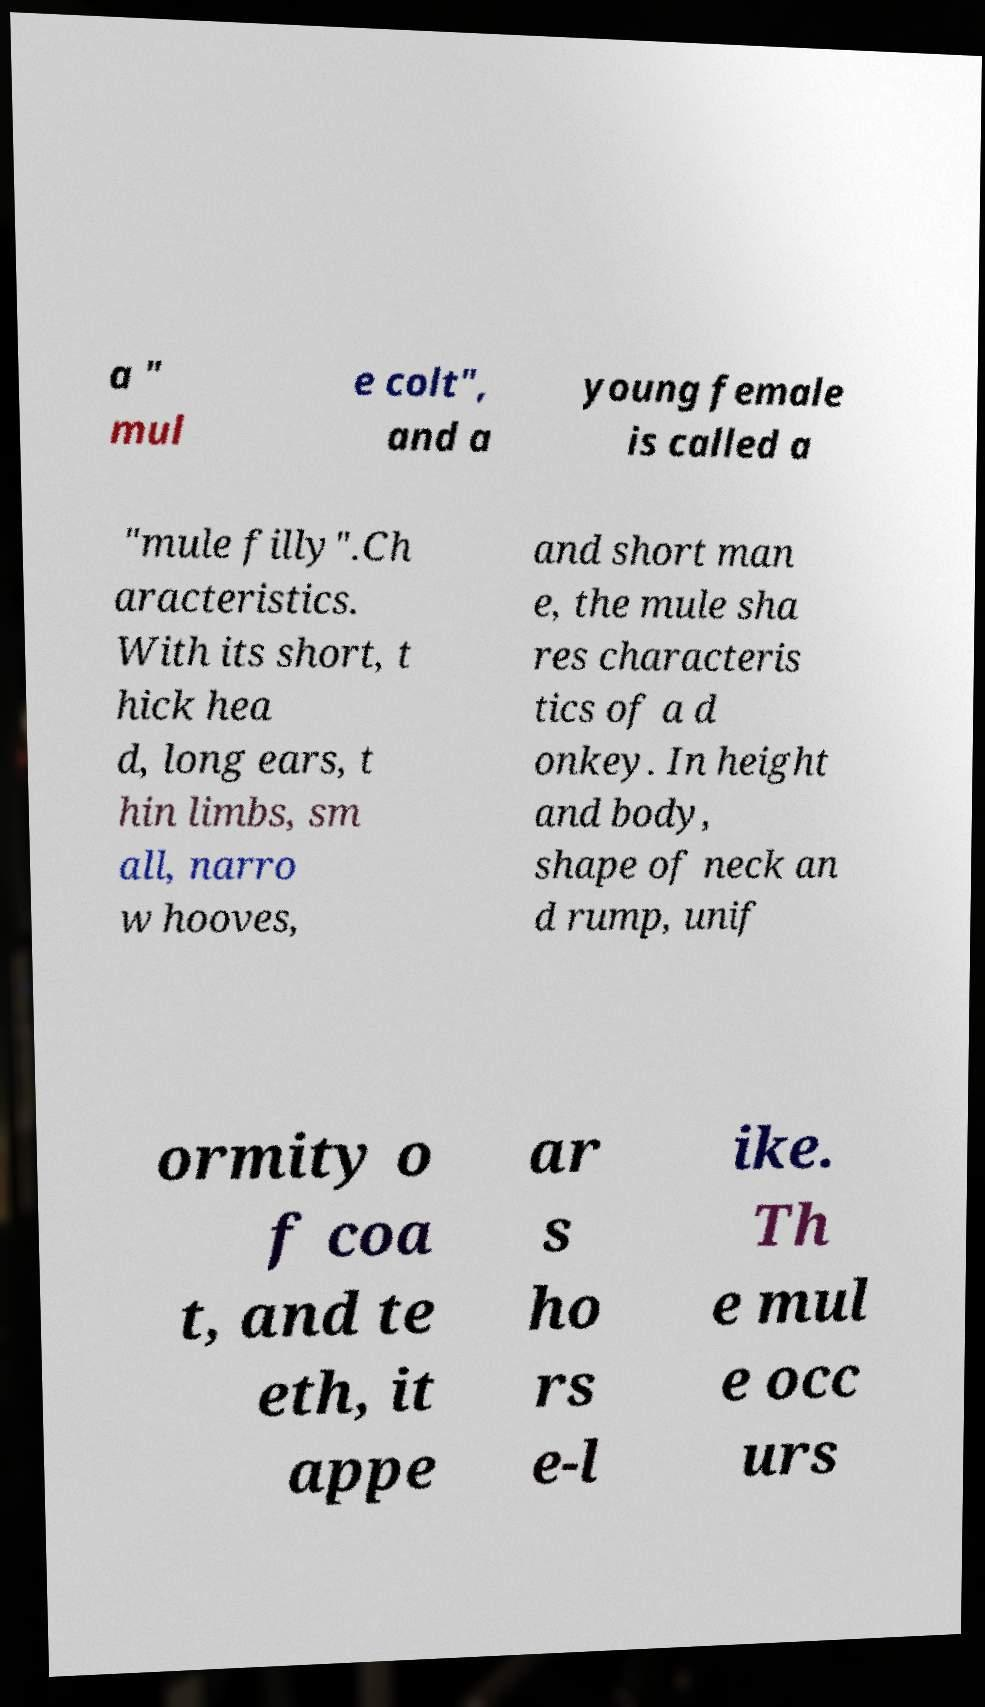Could you extract and type out the text from this image? a " mul e colt", and a young female is called a "mule filly".Ch aracteristics. With its short, t hick hea d, long ears, t hin limbs, sm all, narro w hooves, and short man e, the mule sha res characteris tics of a d onkey. In height and body, shape of neck an d rump, unif ormity o f coa t, and te eth, it appe ar s ho rs e-l ike. Th e mul e occ urs 